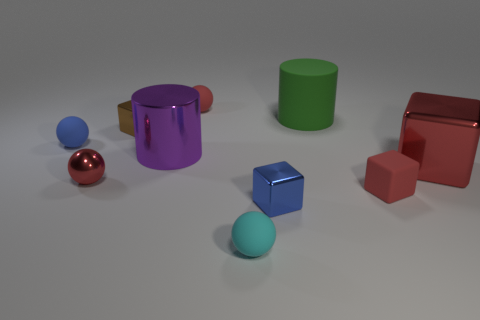What shapes are present in the image and what are their colors? The image features a variety of geometric shapes, including a large red cube, a small maroon cube, a big purple cylinder, a small blue sphere, a brown rectangular prism, a small cyan sphere, and a large green cylinder, all presented with a glossy finish on a neutral background. 